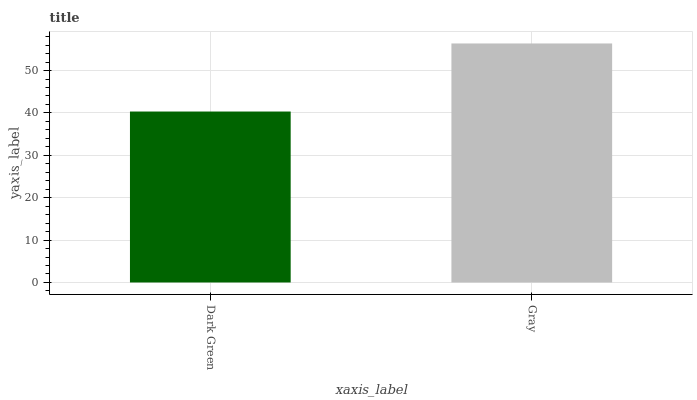Is Dark Green the minimum?
Answer yes or no. Yes. Is Gray the maximum?
Answer yes or no. Yes. Is Gray the minimum?
Answer yes or no. No. Is Gray greater than Dark Green?
Answer yes or no. Yes. Is Dark Green less than Gray?
Answer yes or no. Yes. Is Dark Green greater than Gray?
Answer yes or no. No. Is Gray less than Dark Green?
Answer yes or no. No. Is Gray the high median?
Answer yes or no. Yes. Is Dark Green the low median?
Answer yes or no. Yes. Is Dark Green the high median?
Answer yes or no. No. Is Gray the low median?
Answer yes or no. No. 